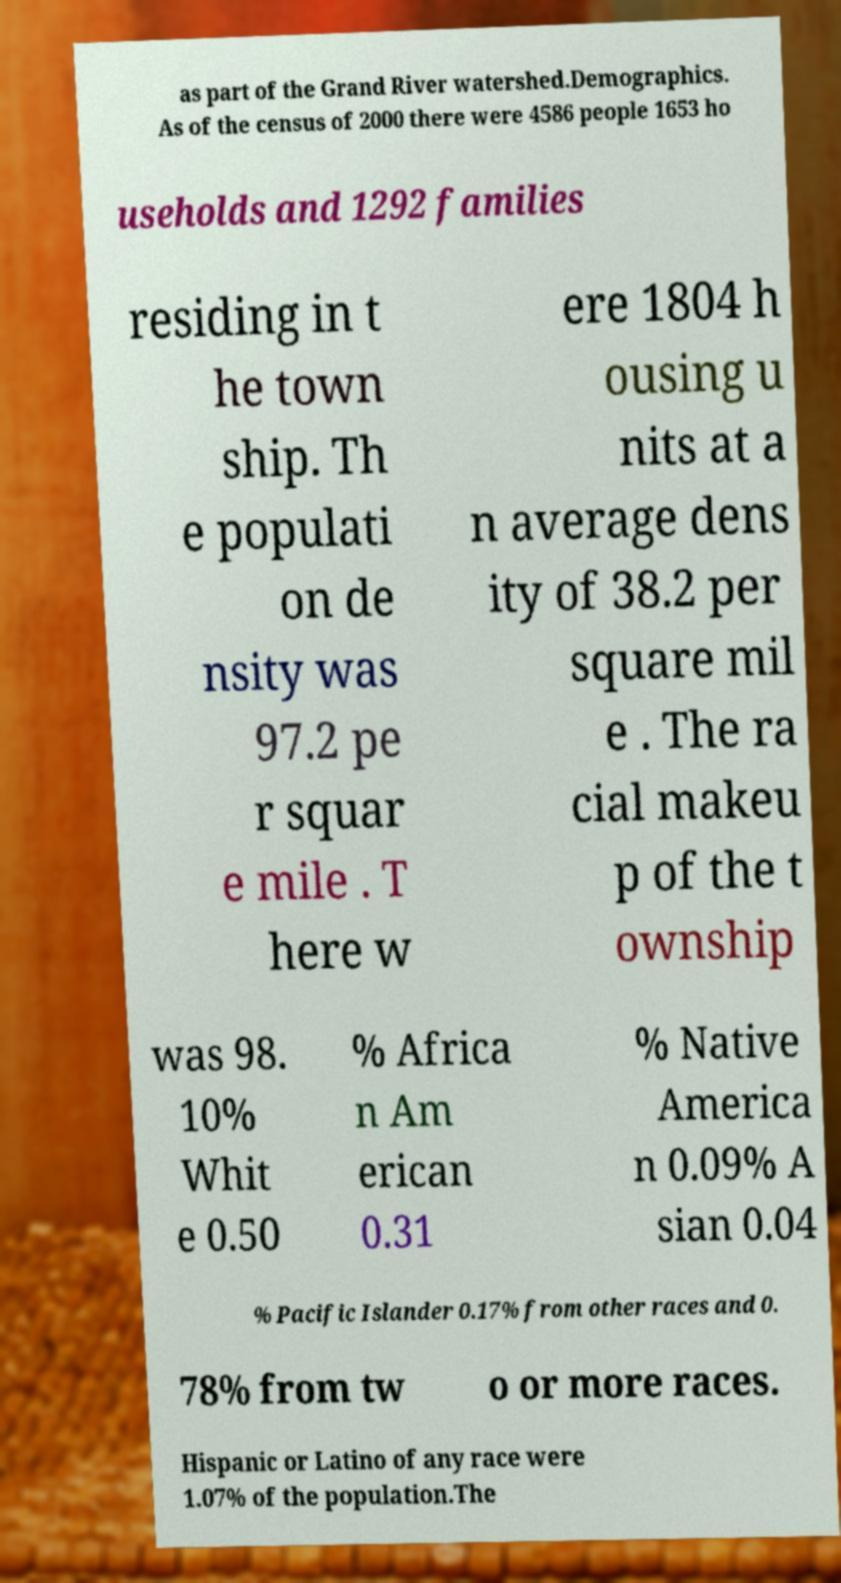Can you read and provide the text displayed in the image?This photo seems to have some interesting text. Can you extract and type it out for me? as part of the Grand River watershed.Demographics. As of the census of 2000 there were 4586 people 1653 ho useholds and 1292 families residing in t he town ship. Th e populati on de nsity was 97.2 pe r squar e mile . T here w ere 1804 h ousing u nits at a n average dens ity of 38.2 per square mil e . The ra cial makeu p of the t ownship was 98. 10% Whit e 0.50 % Africa n Am erican 0.31 % Native America n 0.09% A sian 0.04 % Pacific Islander 0.17% from other races and 0. 78% from tw o or more races. Hispanic or Latino of any race were 1.07% of the population.The 